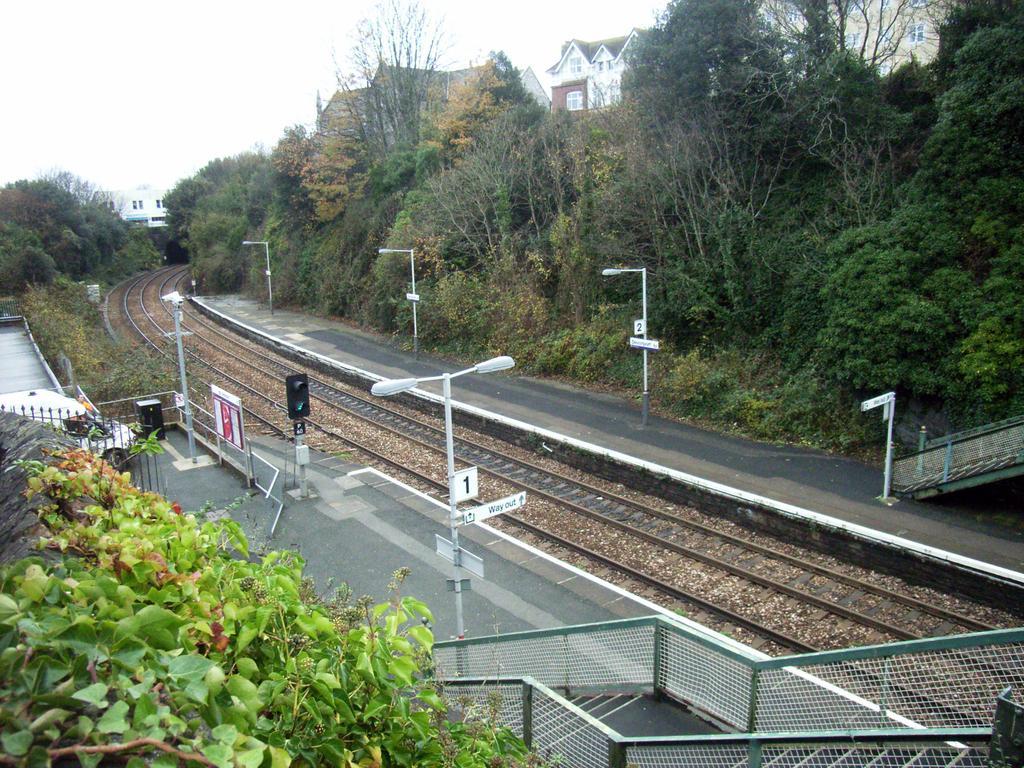Can you describe this image briefly? In the foreground of this picture, there are plants on the wall. In the background, we can see poles, stairs, railway track, signal pole, trees, side path, buildings and the sky. 